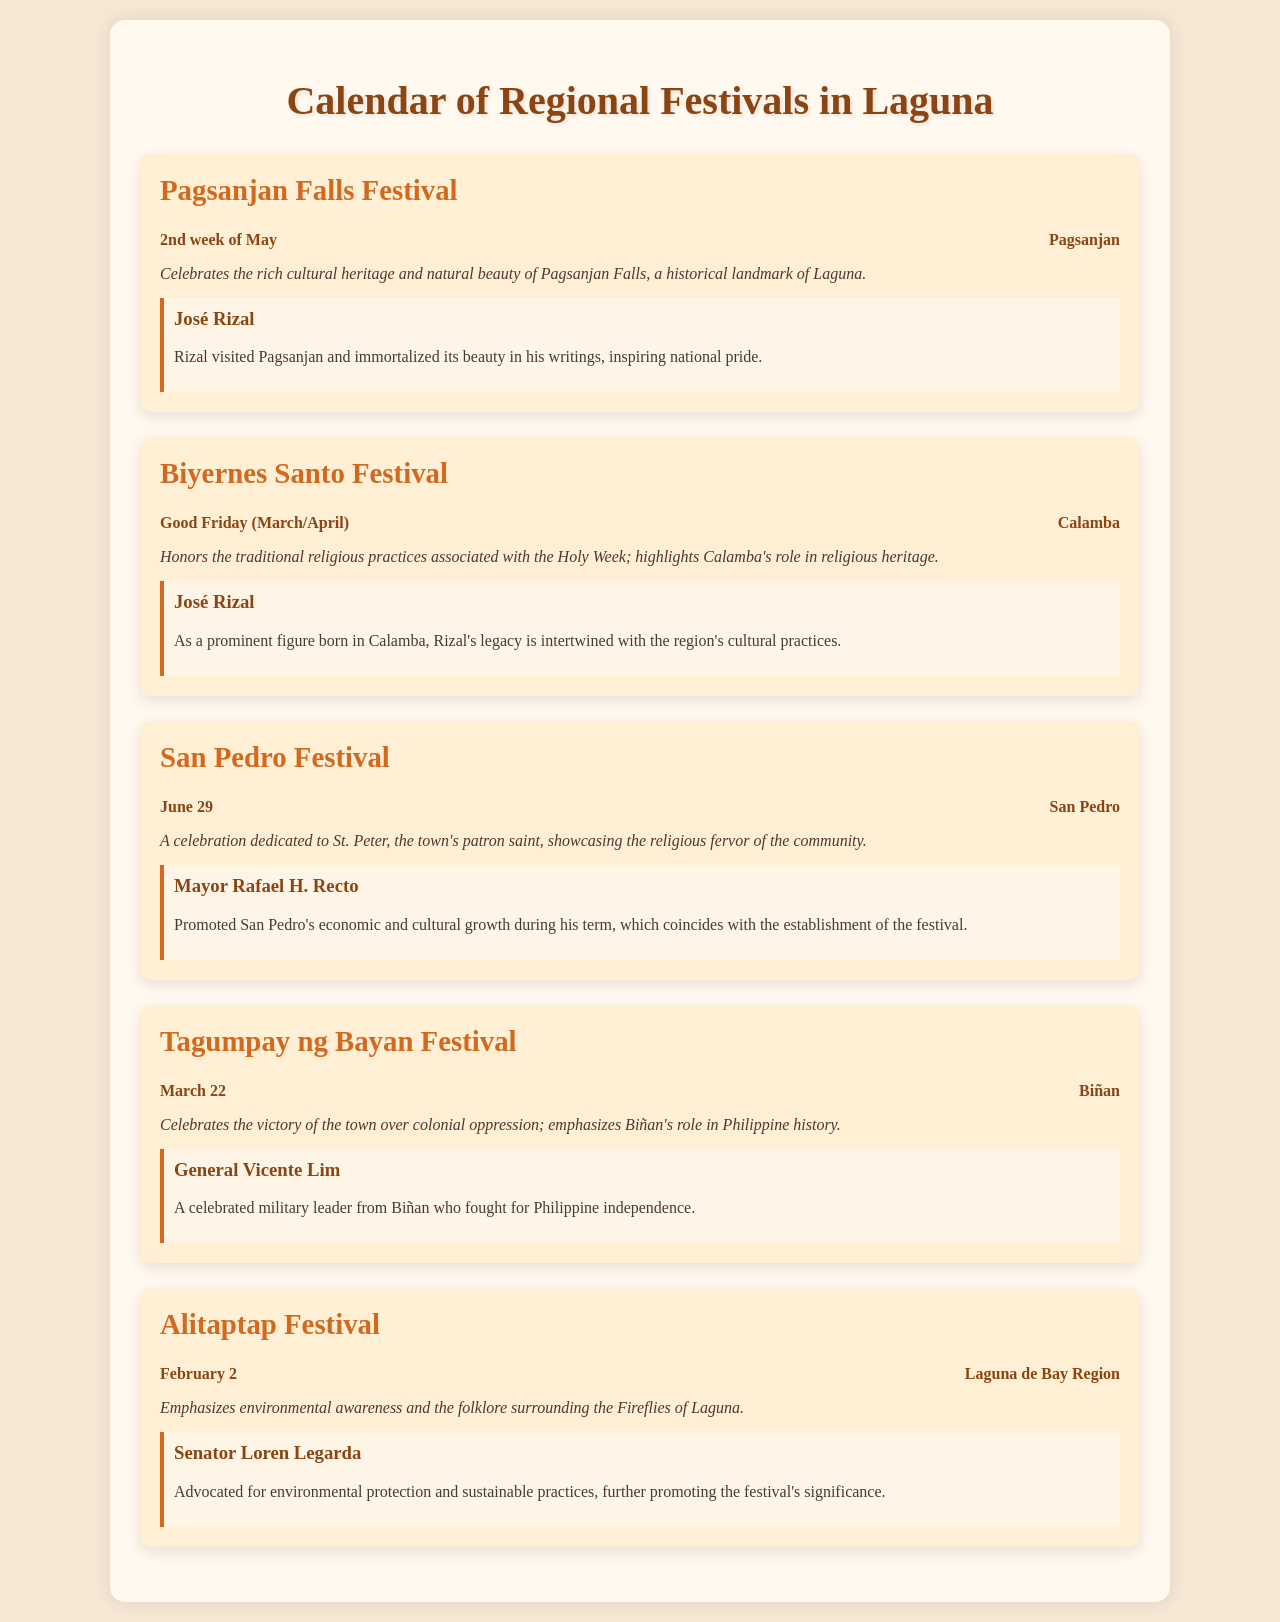What festival is celebrated in Pagsanjan? The document lists the Pagsanjan Falls Festival as the festival celebrated in Pagsanjan.
Answer: Pagsanjan Falls Festival When does the Biyernes Santo Festival occur? According to the document, the Biyernes Santo Festival occurs on Good Friday, which varies between March and April.
Answer: Good Friday (March/April) Who is the notable figure associated with the San Pedro Festival? The document mentions Mayor Rafael H. Recto as the notable figure associated with the San Pedro Festival.
Answer: Mayor Rafael H. Recto What is the historical significance of the Tagumpay ng Bayan Festival? The document states that the Tagumpay ng Bayan Festival celebrates the victory of the town over colonial oppression, emphasizing Biñan's role in Philippine history.
Answer: Celebrates the victory over colonial oppression Which festival emphasizes environmental awareness? The Alitaptap Festival emphasizes environmental awareness according to the document.
Answer: Alitaptap Festival What date is the San Pedro Festival celebrated? The San Pedro Festival is celebrated on June 29, as indicated in the document.
Answer: June 29 Which notable figure is associated with environmental advocacy in the document? Senator Loren Legarda is identified as the notable figure associated with environmental advocacy in the document.
Answer: Senator Loren Legarda What is the historical landmark celebrated during the Pagsanjan Falls Festival? The document states that the Pagsanjan Falls Festival celebrates the natural beauty of Pagsanjan Falls, a historical landmark of Laguna.
Answer: Pagsanjan Falls What does the Alitaptap Festival showcase in terms of folklore? The document indicates that the Alitaptap Festival showcases the folklore surrounding the Fireflies of Laguna.
Answer: Fireflies of Laguna 